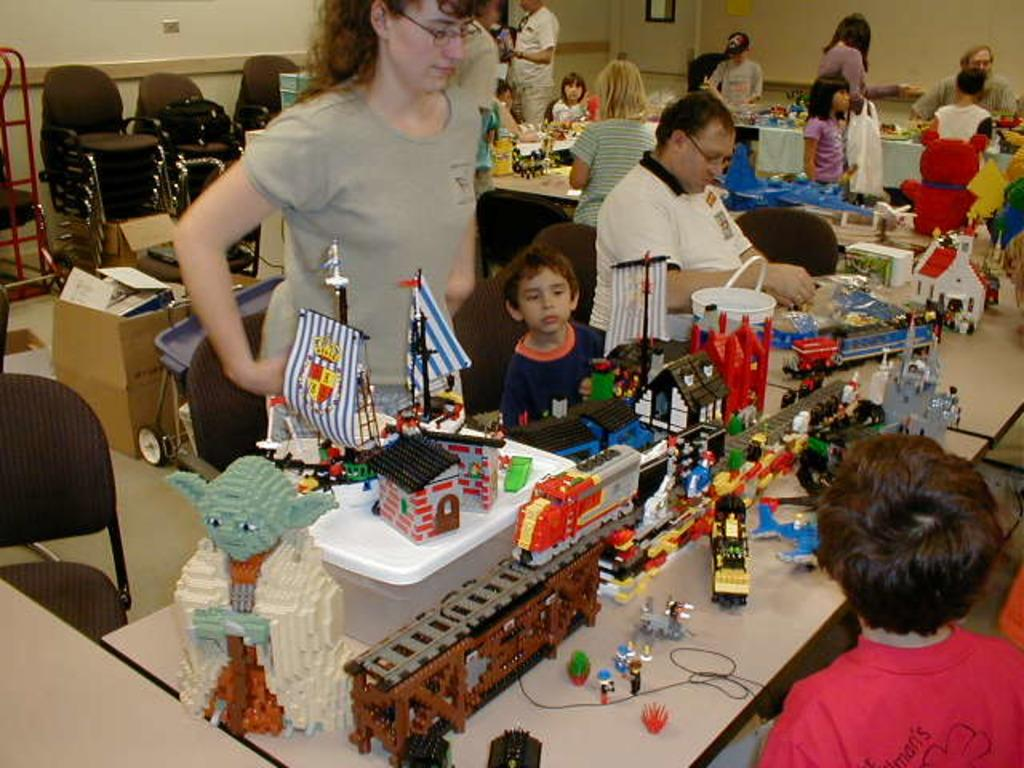What are the people in the image doing? There are persons standing and sitting in the image. What can be seen on a table in the background? There are toys on a table in the background. What other objects are visible in the background? There are cart boards and chairs in the background. What is visible behind the people and objects in the image? There is a wall visible in the background. Can you tell me how many shoes the kitty is wearing in the image? There is no kitty present in the image, and therefore no shoes to count. What type of shake is being prepared by the people in the image? There is no shake preparation or reference to a shake in the image. 